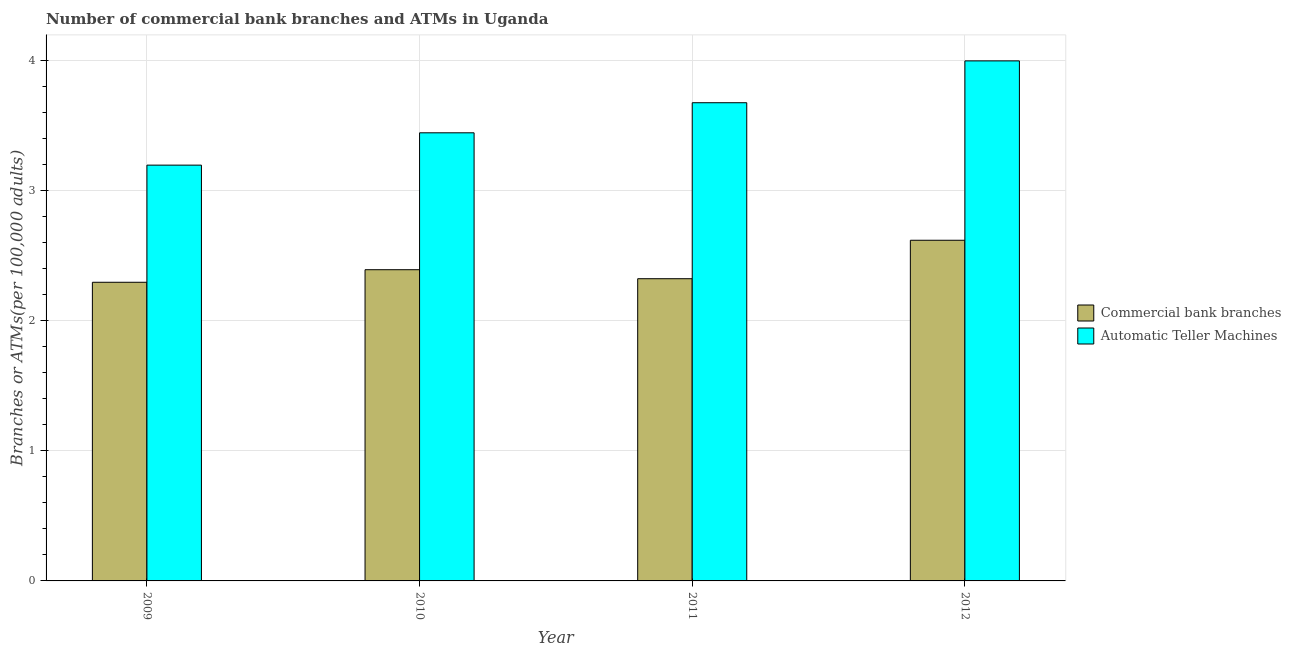Are the number of bars per tick equal to the number of legend labels?
Give a very brief answer. Yes. Are the number of bars on each tick of the X-axis equal?
Ensure brevity in your answer.  Yes. How many bars are there on the 3rd tick from the left?
Offer a very short reply. 2. How many bars are there on the 1st tick from the right?
Provide a short and direct response. 2. What is the number of atms in 2010?
Provide a short and direct response. 3.45. Across all years, what is the maximum number of commercal bank branches?
Your response must be concise. 2.62. Across all years, what is the minimum number of commercal bank branches?
Keep it short and to the point. 2.3. In which year was the number of commercal bank branches maximum?
Provide a succinct answer. 2012. What is the total number of commercal bank branches in the graph?
Your answer should be very brief. 9.63. What is the difference between the number of atms in 2009 and that in 2011?
Provide a succinct answer. -0.48. What is the difference between the number of commercal bank branches in 2009 and the number of atms in 2010?
Keep it short and to the point. -0.1. What is the average number of atms per year?
Offer a terse response. 3.58. What is the ratio of the number of atms in 2009 to that in 2011?
Your answer should be very brief. 0.87. Is the difference between the number of atms in 2009 and 2010 greater than the difference between the number of commercal bank branches in 2009 and 2010?
Your answer should be very brief. No. What is the difference between the highest and the second highest number of commercal bank branches?
Provide a short and direct response. 0.23. What is the difference between the highest and the lowest number of commercal bank branches?
Your answer should be compact. 0.32. Is the sum of the number of atms in 2009 and 2010 greater than the maximum number of commercal bank branches across all years?
Ensure brevity in your answer.  Yes. What does the 1st bar from the left in 2011 represents?
Give a very brief answer. Commercial bank branches. What does the 2nd bar from the right in 2010 represents?
Offer a very short reply. Commercial bank branches. How many bars are there?
Your response must be concise. 8. How many years are there in the graph?
Your response must be concise. 4. Are the values on the major ticks of Y-axis written in scientific E-notation?
Provide a short and direct response. No. Where does the legend appear in the graph?
Your answer should be compact. Center right. How are the legend labels stacked?
Ensure brevity in your answer.  Vertical. What is the title of the graph?
Give a very brief answer. Number of commercial bank branches and ATMs in Uganda. Does "From World Bank" appear as one of the legend labels in the graph?
Provide a short and direct response. No. What is the label or title of the Y-axis?
Offer a terse response. Branches or ATMs(per 100,0 adults). What is the Branches or ATMs(per 100,000 adults) of Commercial bank branches in 2009?
Your answer should be compact. 2.3. What is the Branches or ATMs(per 100,000 adults) of Automatic Teller Machines in 2009?
Offer a very short reply. 3.2. What is the Branches or ATMs(per 100,000 adults) in Commercial bank branches in 2010?
Keep it short and to the point. 2.39. What is the Branches or ATMs(per 100,000 adults) of Automatic Teller Machines in 2010?
Offer a terse response. 3.45. What is the Branches or ATMs(per 100,000 adults) in Commercial bank branches in 2011?
Provide a succinct answer. 2.32. What is the Branches or ATMs(per 100,000 adults) of Automatic Teller Machines in 2011?
Give a very brief answer. 3.68. What is the Branches or ATMs(per 100,000 adults) in Commercial bank branches in 2012?
Your answer should be very brief. 2.62. What is the Branches or ATMs(per 100,000 adults) of Automatic Teller Machines in 2012?
Make the answer very short. 4. Across all years, what is the maximum Branches or ATMs(per 100,000 adults) in Commercial bank branches?
Provide a succinct answer. 2.62. Across all years, what is the maximum Branches or ATMs(per 100,000 adults) in Automatic Teller Machines?
Provide a short and direct response. 4. Across all years, what is the minimum Branches or ATMs(per 100,000 adults) in Commercial bank branches?
Keep it short and to the point. 2.3. Across all years, what is the minimum Branches or ATMs(per 100,000 adults) of Automatic Teller Machines?
Provide a short and direct response. 3.2. What is the total Branches or ATMs(per 100,000 adults) in Commercial bank branches in the graph?
Offer a terse response. 9.63. What is the total Branches or ATMs(per 100,000 adults) in Automatic Teller Machines in the graph?
Keep it short and to the point. 14.32. What is the difference between the Branches or ATMs(per 100,000 adults) in Commercial bank branches in 2009 and that in 2010?
Give a very brief answer. -0.1. What is the difference between the Branches or ATMs(per 100,000 adults) in Automatic Teller Machines in 2009 and that in 2010?
Offer a terse response. -0.25. What is the difference between the Branches or ATMs(per 100,000 adults) of Commercial bank branches in 2009 and that in 2011?
Your answer should be very brief. -0.03. What is the difference between the Branches or ATMs(per 100,000 adults) in Automatic Teller Machines in 2009 and that in 2011?
Your response must be concise. -0.48. What is the difference between the Branches or ATMs(per 100,000 adults) in Commercial bank branches in 2009 and that in 2012?
Your answer should be very brief. -0.32. What is the difference between the Branches or ATMs(per 100,000 adults) of Automatic Teller Machines in 2009 and that in 2012?
Offer a very short reply. -0.8. What is the difference between the Branches or ATMs(per 100,000 adults) in Commercial bank branches in 2010 and that in 2011?
Your answer should be compact. 0.07. What is the difference between the Branches or ATMs(per 100,000 adults) in Automatic Teller Machines in 2010 and that in 2011?
Your response must be concise. -0.23. What is the difference between the Branches or ATMs(per 100,000 adults) of Commercial bank branches in 2010 and that in 2012?
Make the answer very short. -0.23. What is the difference between the Branches or ATMs(per 100,000 adults) of Automatic Teller Machines in 2010 and that in 2012?
Provide a short and direct response. -0.55. What is the difference between the Branches or ATMs(per 100,000 adults) in Commercial bank branches in 2011 and that in 2012?
Make the answer very short. -0.3. What is the difference between the Branches or ATMs(per 100,000 adults) in Automatic Teller Machines in 2011 and that in 2012?
Offer a very short reply. -0.32. What is the difference between the Branches or ATMs(per 100,000 adults) in Commercial bank branches in 2009 and the Branches or ATMs(per 100,000 adults) in Automatic Teller Machines in 2010?
Offer a terse response. -1.15. What is the difference between the Branches or ATMs(per 100,000 adults) in Commercial bank branches in 2009 and the Branches or ATMs(per 100,000 adults) in Automatic Teller Machines in 2011?
Give a very brief answer. -1.38. What is the difference between the Branches or ATMs(per 100,000 adults) of Commercial bank branches in 2009 and the Branches or ATMs(per 100,000 adults) of Automatic Teller Machines in 2012?
Keep it short and to the point. -1.7. What is the difference between the Branches or ATMs(per 100,000 adults) in Commercial bank branches in 2010 and the Branches or ATMs(per 100,000 adults) in Automatic Teller Machines in 2011?
Ensure brevity in your answer.  -1.28. What is the difference between the Branches or ATMs(per 100,000 adults) of Commercial bank branches in 2010 and the Branches or ATMs(per 100,000 adults) of Automatic Teller Machines in 2012?
Keep it short and to the point. -1.61. What is the difference between the Branches or ATMs(per 100,000 adults) of Commercial bank branches in 2011 and the Branches or ATMs(per 100,000 adults) of Automatic Teller Machines in 2012?
Your answer should be compact. -1.68. What is the average Branches or ATMs(per 100,000 adults) of Commercial bank branches per year?
Keep it short and to the point. 2.41. What is the average Branches or ATMs(per 100,000 adults) of Automatic Teller Machines per year?
Your answer should be compact. 3.58. In the year 2009, what is the difference between the Branches or ATMs(per 100,000 adults) in Commercial bank branches and Branches or ATMs(per 100,000 adults) in Automatic Teller Machines?
Your answer should be very brief. -0.9. In the year 2010, what is the difference between the Branches or ATMs(per 100,000 adults) of Commercial bank branches and Branches or ATMs(per 100,000 adults) of Automatic Teller Machines?
Keep it short and to the point. -1.05. In the year 2011, what is the difference between the Branches or ATMs(per 100,000 adults) in Commercial bank branches and Branches or ATMs(per 100,000 adults) in Automatic Teller Machines?
Ensure brevity in your answer.  -1.35. In the year 2012, what is the difference between the Branches or ATMs(per 100,000 adults) in Commercial bank branches and Branches or ATMs(per 100,000 adults) in Automatic Teller Machines?
Ensure brevity in your answer.  -1.38. What is the ratio of the Branches or ATMs(per 100,000 adults) in Commercial bank branches in 2009 to that in 2010?
Your answer should be compact. 0.96. What is the ratio of the Branches or ATMs(per 100,000 adults) in Automatic Teller Machines in 2009 to that in 2010?
Your response must be concise. 0.93. What is the ratio of the Branches or ATMs(per 100,000 adults) of Automatic Teller Machines in 2009 to that in 2011?
Your answer should be compact. 0.87. What is the ratio of the Branches or ATMs(per 100,000 adults) in Commercial bank branches in 2009 to that in 2012?
Offer a terse response. 0.88. What is the ratio of the Branches or ATMs(per 100,000 adults) of Automatic Teller Machines in 2009 to that in 2012?
Offer a terse response. 0.8. What is the ratio of the Branches or ATMs(per 100,000 adults) in Commercial bank branches in 2010 to that in 2011?
Give a very brief answer. 1.03. What is the ratio of the Branches or ATMs(per 100,000 adults) in Automatic Teller Machines in 2010 to that in 2011?
Give a very brief answer. 0.94. What is the ratio of the Branches or ATMs(per 100,000 adults) in Commercial bank branches in 2010 to that in 2012?
Keep it short and to the point. 0.91. What is the ratio of the Branches or ATMs(per 100,000 adults) of Automatic Teller Machines in 2010 to that in 2012?
Keep it short and to the point. 0.86. What is the ratio of the Branches or ATMs(per 100,000 adults) in Commercial bank branches in 2011 to that in 2012?
Your answer should be compact. 0.89. What is the ratio of the Branches or ATMs(per 100,000 adults) of Automatic Teller Machines in 2011 to that in 2012?
Your answer should be compact. 0.92. What is the difference between the highest and the second highest Branches or ATMs(per 100,000 adults) in Commercial bank branches?
Provide a succinct answer. 0.23. What is the difference between the highest and the second highest Branches or ATMs(per 100,000 adults) in Automatic Teller Machines?
Provide a succinct answer. 0.32. What is the difference between the highest and the lowest Branches or ATMs(per 100,000 adults) of Commercial bank branches?
Give a very brief answer. 0.32. What is the difference between the highest and the lowest Branches or ATMs(per 100,000 adults) of Automatic Teller Machines?
Keep it short and to the point. 0.8. 